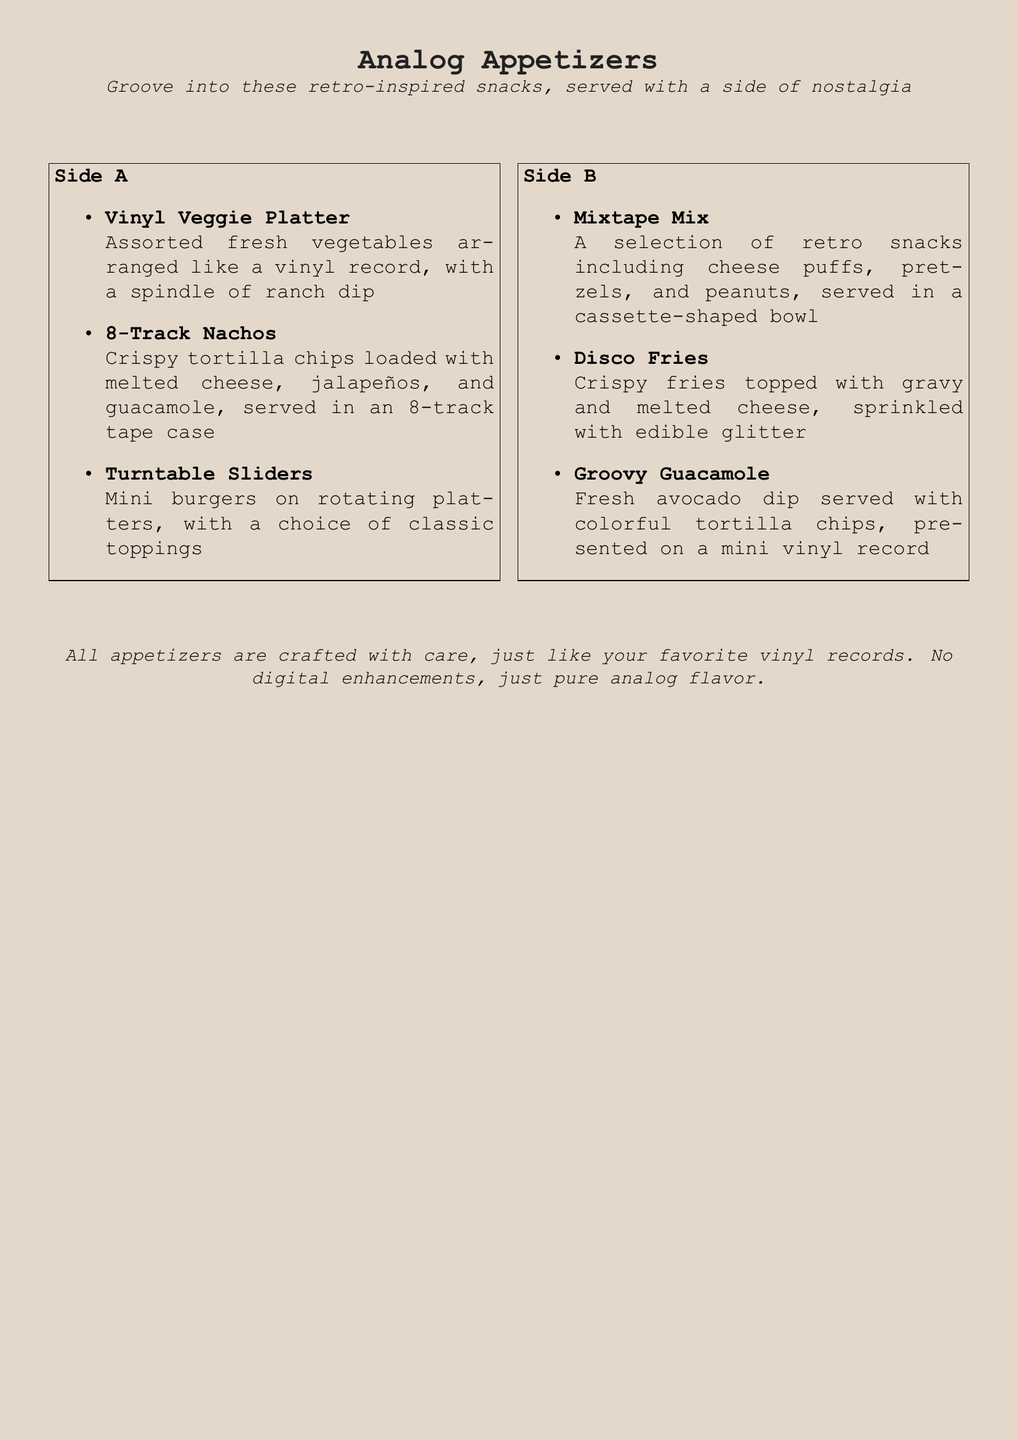What is the title of this menu section? The title is clearly stated at the top of the document as "Analog Appetizers".
Answer: Analog Appetizers How many items are listed on Side A? Counting the items in the Side A section reveals there are three appetizers listed.
Answer: 3 What type of dip is served with the Vinyl Veggie Platter? The description specifies that the Vinyl Veggie Platter is served with a ranch dip.
Answer: ranch dip What snack is served in an 8-track tape case? The menu describes "8-Track Nachos" as being served in an 8-track tape case.
Answer: 8-Track Nachos Which appetizer features edible glitter? The "Disco Fries" are specifically mentioned to be topped with edible glitter.
Answer: Disco Fries What serves as the bowl for the Mixtape Mix? The Mixtape Mix is served in a cassette-shaped bowl.
Answer: cassette-shaped bowl What is the presentation style of the Groovy Guacamole? The Groovy Guacamole is presented on a mini vinyl record.
Answer: mini vinyl record Is there a choice offered for the Turntable Sliders? Yes, the description indicates there is a choice of classic toppings for the sliders.
Answer: classic toppings What flavor theme does the statement at the bottom suggest? The statement suggests a theme of crafting with care and purely analog flavors.
Answer: analog flavor 